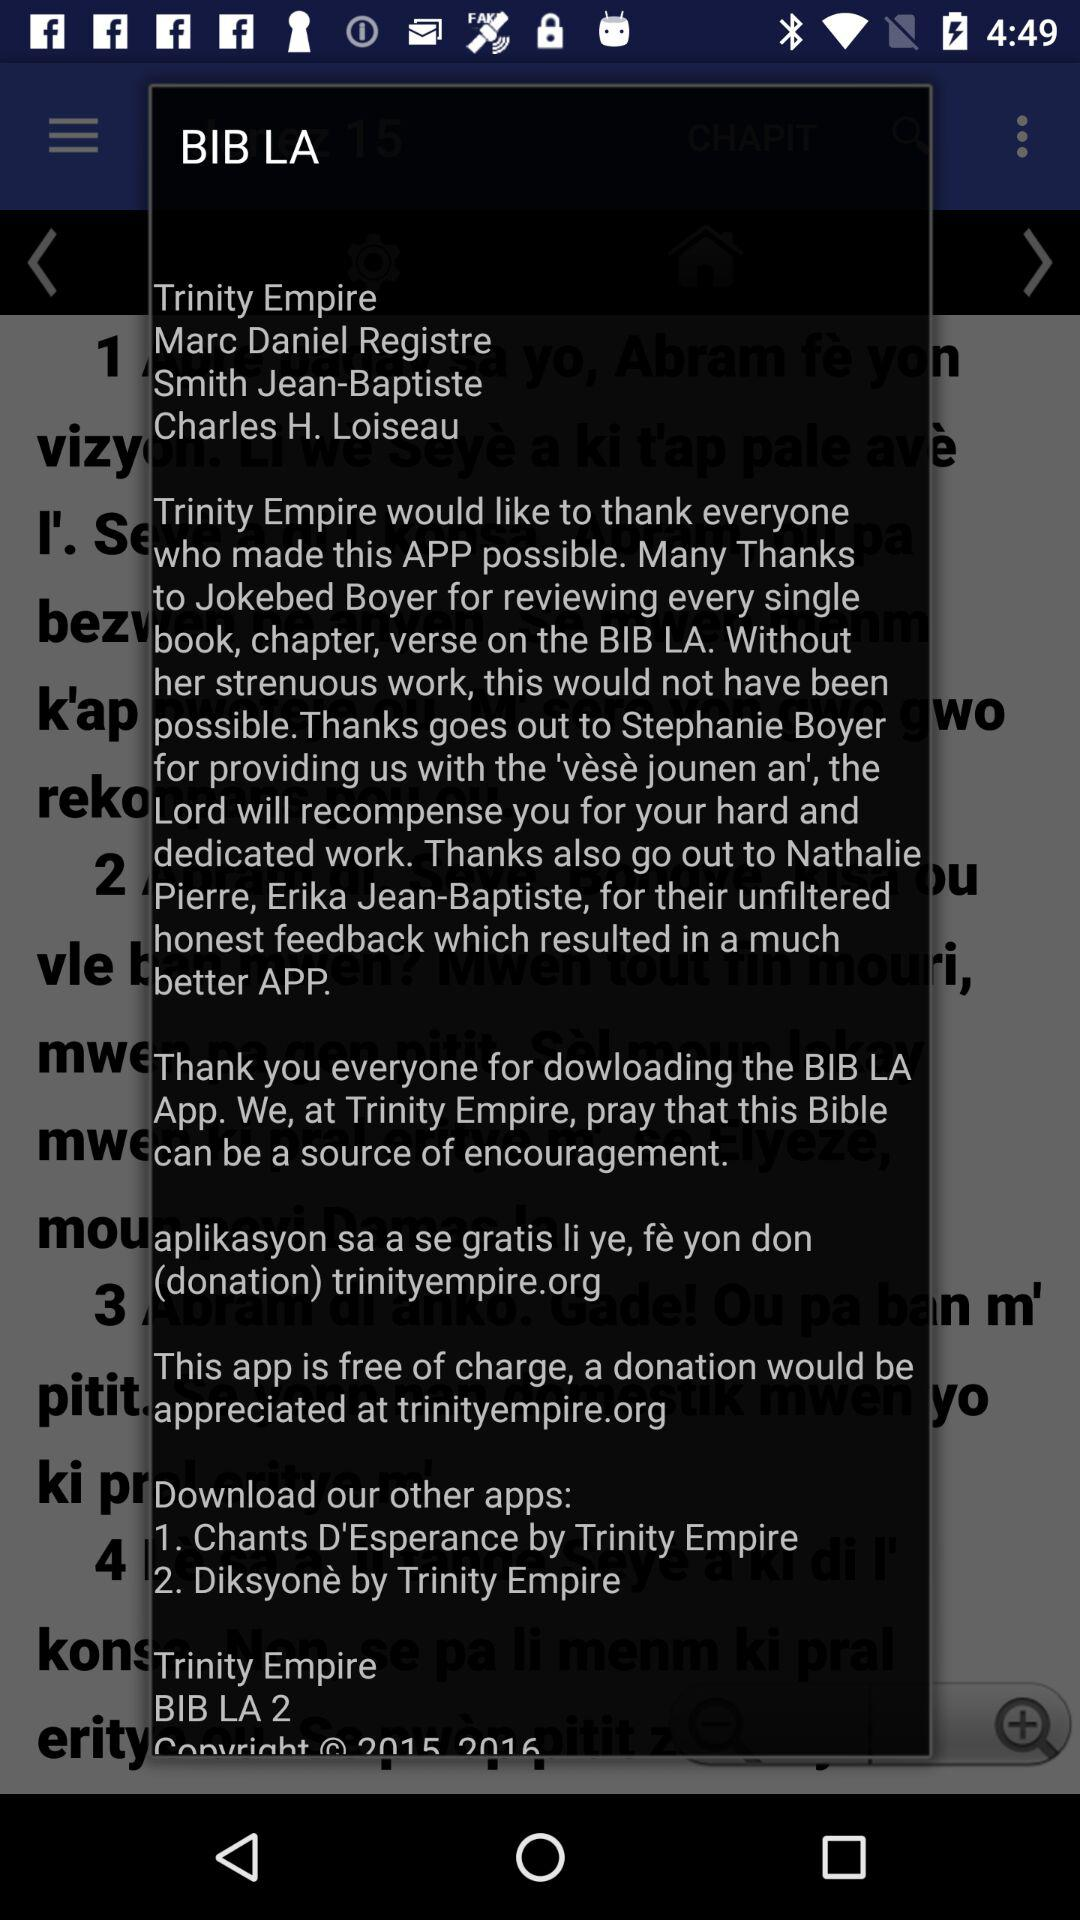How many apps does Trinity Empire have?
Answer the question using a single word or phrase. 2 